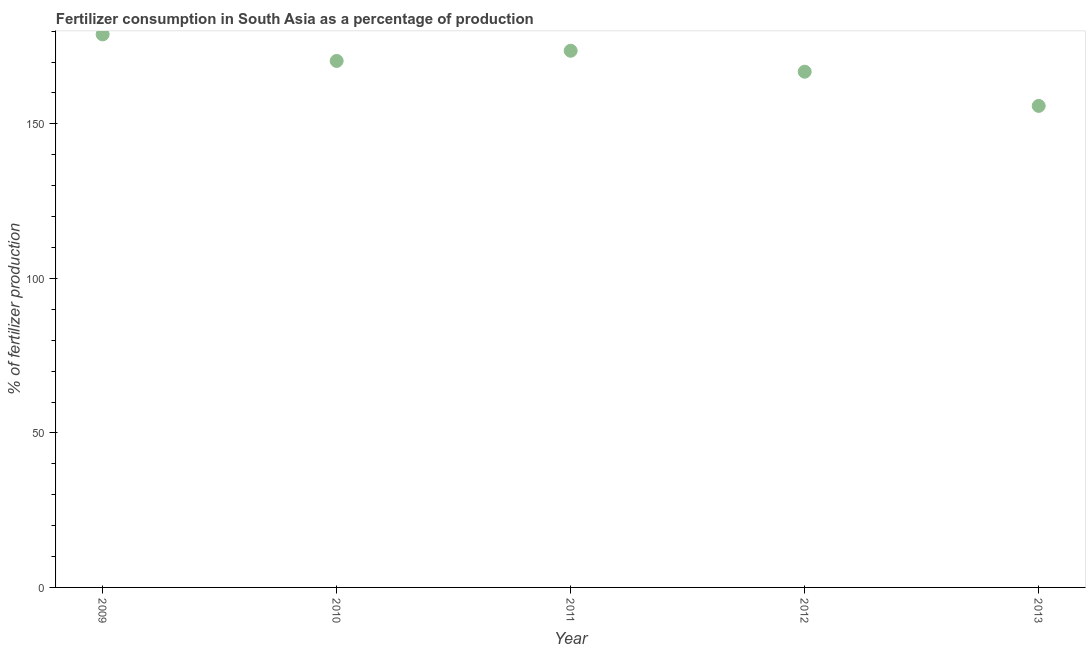What is the amount of fertilizer consumption in 2013?
Provide a short and direct response. 155.81. Across all years, what is the maximum amount of fertilizer consumption?
Provide a short and direct response. 178.95. Across all years, what is the minimum amount of fertilizer consumption?
Give a very brief answer. 155.81. In which year was the amount of fertilizer consumption maximum?
Provide a succinct answer. 2009. What is the sum of the amount of fertilizer consumption?
Make the answer very short. 845.66. What is the difference between the amount of fertilizer consumption in 2011 and 2013?
Your answer should be very brief. 17.84. What is the average amount of fertilizer consumption per year?
Offer a terse response. 169.13. What is the median amount of fertilizer consumption?
Provide a succinct answer. 170.36. Do a majority of the years between 2013 and 2010 (inclusive) have amount of fertilizer consumption greater than 90 %?
Provide a succinct answer. Yes. What is the ratio of the amount of fertilizer consumption in 2011 to that in 2013?
Keep it short and to the point. 1.11. Is the difference between the amount of fertilizer consumption in 2009 and 2013 greater than the difference between any two years?
Provide a succinct answer. Yes. What is the difference between the highest and the second highest amount of fertilizer consumption?
Keep it short and to the point. 5.29. Is the sum of the amount of fertilizer consumption in 2010 and 2013 greater than the maximum amount of fertilizer consumption across all years?
Your answer should be compact. Yes. What is the difference between the highest and the lowest amount of fertilizer consumption?
Offer a terse response. 23.14. Does the amount of fertilizer consumption monotonically increase over the years?
Your response must be concise. No. Are the values on the major ticks of Y-axis written in scientific E-notation?
Provide a succinct answer. No. Does the graph contain any zero values?
Provide a short and direct response. No. Does the graph contain grids?
Keep it short and to the point. No. What is the title of the graph?
Provide a succinct answer. Fertilizer consumption in South Asia as a percentage of production. What is the label or title of the Y-axis?
Offer a very short reply. % of fertilizer production. What is the % of fertilizer production in 2009?
Provide a succinct answer. 178.95. What is the % of fertilizer production in 2010?
Ensure brevity in your answer.  170.36. What is the % of fertilizer production in 2011?
Offer a terse response. 173.66. What is the % of fertilizer production in 2012?
Offer a very short reply. 166.88. What is the % of fertilizer production in 2013?
Your answer should be compact. 155.81. What is the difference between the % of fertilizer production in 2009 and 2010?
Keep it short and to the point. 8.59. What is the difference between the % of fertilizer production in 2009 and 2011?
Offer a terse response. 5.29. What is the difference between the % of fertilizer production in 2009 and 2012?
Give a very brief answer. 12.07. What is the difference between the % of fertilizer production in 2009 and 2013?
Keep it short and to the point. 23.14. What is the difference between the % of fertilizer production in 2010 and 2011?
Offer a very short reply. -3.29. What is the difference between the % of fertilizer production in 2010 and 2012?
Offer a very short reply. 3.49. What is the difference between the % of fertilizer production in 2010 and 2013?
Provide a succinct answer. 14.55. What is the difference between the % of fertilizer production in 2011 and 2012?
Your answer should be compact. 6.78. What is the difference between the % of fertilizer production in 2011 and 2013?
Ensure brevity in your answer.  17.84. What is the difference between the % of fertilizer production in 2012 and 2013?
Keep it short and to the point. 11.06. What is the ratio of the % of fertilizer production in 2009 to that in 2011?
Offer a terse response. 1.03. What is the ratio of the % of fertilizer production in 2009 to that in 2012?
Keep it short and to the point. 1.07. What is the ratio of the % of fertilizer production in 2009 to that in 2013?
Provide a succinct answer. 1.15. What is the ratio of the % of fertilizer production in 2010 to that in 2012?
Your answer should be very brief. 1.02. What is the ratio of the % of fertilizer production in 2010 to that in 2013?
Keep it short and to the point. 1.09. What is the ratio of the % of fertilizer production in 2011 to that in 2012?
Give a very brief answer. 1.04. What is the ratio of the % of fertilizer production in 2011 to that in 2013?
Provide a succinct answer. 1.11. What is the ratio of the % of fertilizer production in 2012 to that in 2013?
Ensure brevity in your answer.  1.07. 